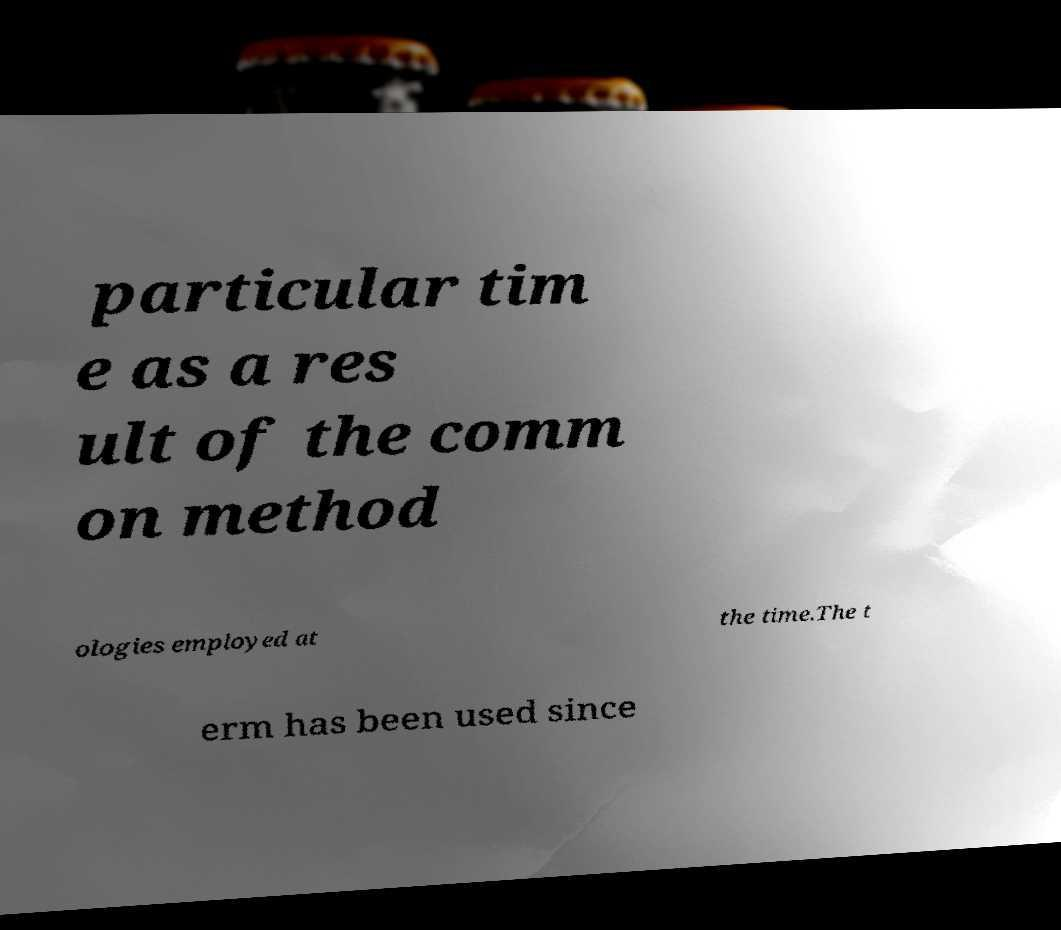I need the written content from this picture converted into text. Can you do that? particular tim e as a res ult of the comm on method ologies employed at the time.The t erm has been used since 